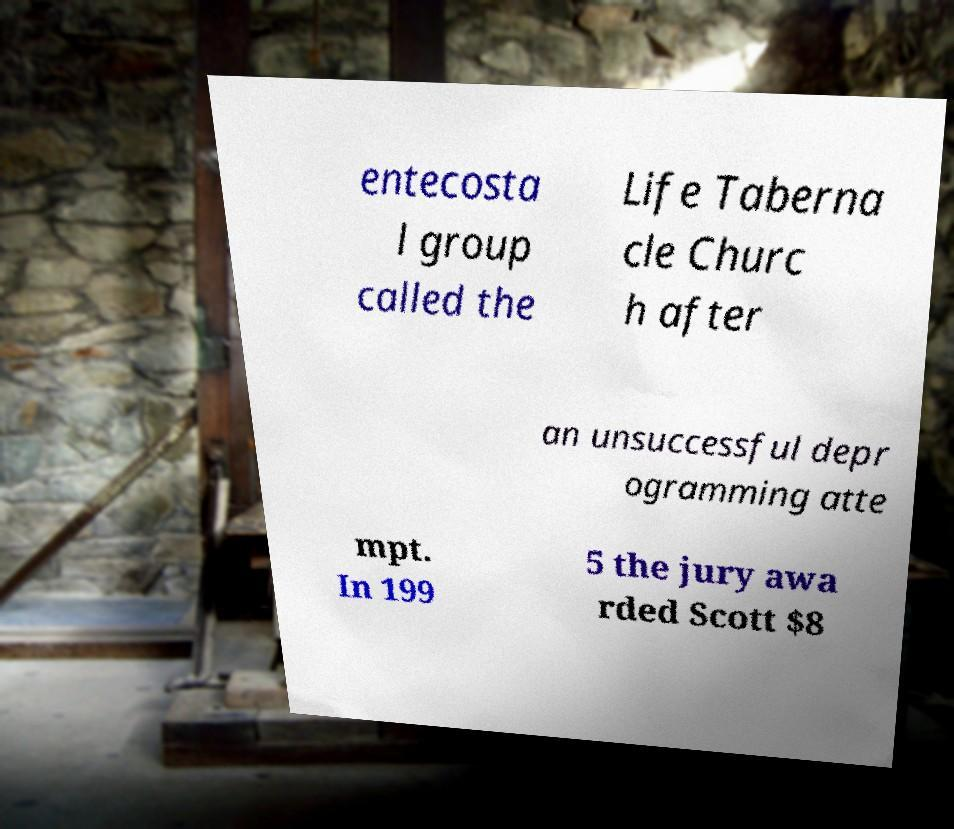What messages or text are displayed in this image? I need them in a readable, typed format. entecosta l group called the Life Taberna cle Churc h after an unsuccessful depr ogramming atte mpt. In 199 5 the jury awa rded Scott $8 